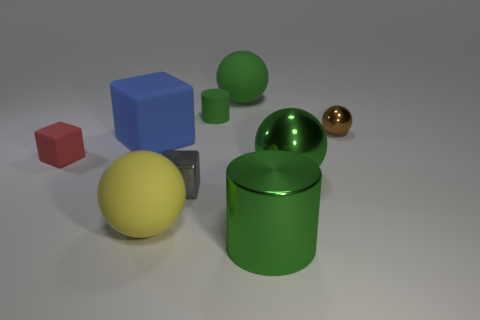Do the gray thing and the tiny object that is to the right of the large shiny cylinder have the same material?
Your answer should be compact. Yes. There is a big matte thing on the left side of the yellow matte ball; is it the same color as the tiny sphere?
Provide a short and direct response. No. How many metallic spheres are both left of the small brown ball and right of the green metallic ball?
Offer a terse response. 0. What number of other objects are the same material as the red block?
Provide a succinct answer. 4. Is the material of the cylinder that is in front of the tiny green matte thing the same as the large blue thing?
Provide a short and direct response. No. What is the size of the shiny sphere that is right of the big green thing to the right of the green object in front of the large green shiny sphere?
Your answer should be very brief. Small. How many other things are the same color as the big block?
Offer a very short reply. 0. There is a brown metallic thing that is the same size as the red rubber thing; what is its shape?
Your answer should be compact. Sphere. How big is the green cylinder that is in front of the small cylinder?
Your answer should be compact. Large. Is the color of the cylinder in front of the tiny green object the same as the big matte sphere to the left of the small green rubber object?
Your answer should be compact. No. 